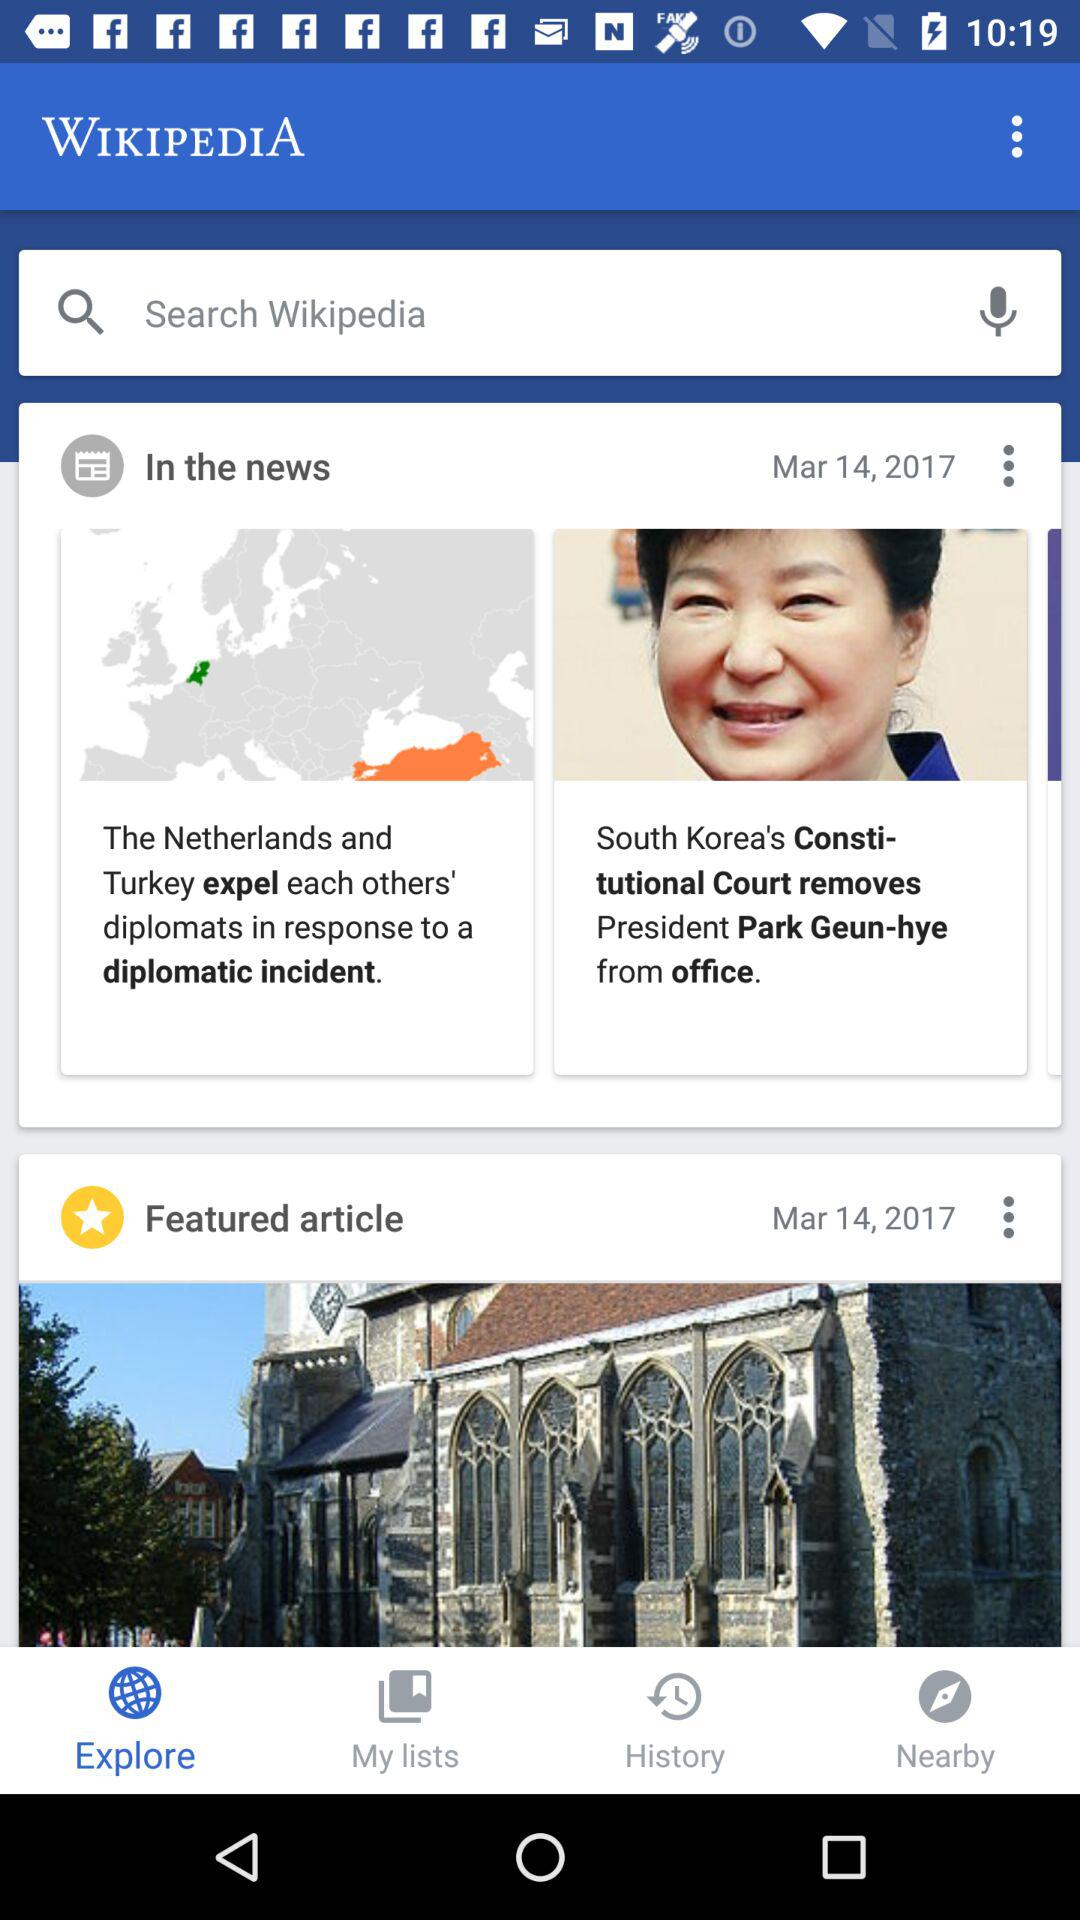When was "In the news" published? "In the news" was published on March 14, 2017. 